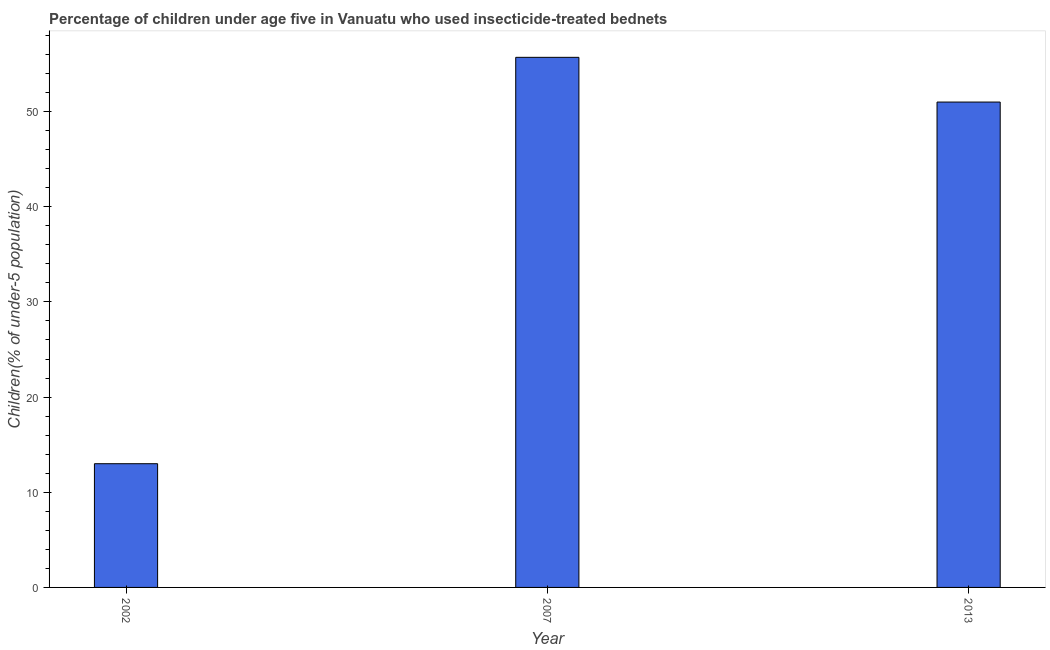Does the graph contain any zero values?
Provide a succinct answer. No. Does the graph contain grids?
Provide a succinct answer. No. What is the title of the graph?
Offer a terse response. Percentage of children under age five in Vanuatu who used insecticide-treated bednets. What is the label or title of the Y-axis?
Ensure brevity in your answer.  Children(% of under-5 population). Across all years, what is the maximum percentage of children who use of insecticide-treated bed nets?
Provide a succinct answer. 55.7. Across all years, what is the minimum percentage of children who use of insecticide-treated bed nets?
Make the answer very short. 13. In which year was the percentage of children who use of insecticide-treated bed nets minimum?
Your answer should be very brief. 2002. What is the sum of the percentage of children who use of insecticide-treated bed nets?
Give a very brief answer. 119.7. What is the average percentage of children who use of insecticide-treated bed nets per year?
Offer a terse response. 39.9. What is the median percentage of children who use of insecticide-treated bed nets?
Provide a succinct answer. 51. In how many years, is the percentage of children who use of insecticide-treated bed nets greater than 10 %?
Give a very brief answer. 3. Do a majority of the years between 2002 and 2007 (inclusive) have percentage of children who use of insecticide-treated bed nets greater than 38 %?
Keep it short and to the point. No. What is the ratio of the percentage of children who use of insecticide-treated bed nets in 2007 to that in 2013?
Give a very brief answer. 1.09. Is the difference between the percentage of children who use of insecticide-treated bed nets in 2007 and 2013 greater than the difference between any two years?
Keep it short and to the point. No. What is the difference between the highest and the second highest percentage of children who use of insecticide-treated bed nets?
Offer a very short reply. 4.7. What is the difference between the highest and the lowest percentage of children who use of insecticide-treated bed nets?
Your response must be concise. 42.7. What is the Children(% of under-5 population) of 2007?
Give a very brief answer. 55.7. What is the Children(% of under-5 population) in 2013?
Offer a terse response. 51. What is the difference between the Children(% of under-5 population) in 2002 and 2007?
Offer a terse response. -42.7. What is the difference between the Children(% of under-5 population) in 2002 and 2013?
Offer a terse response. -38. What is the ratio of the Children(% of under-5 population) in 2002 to that in 2007?
Give a very brief answer. 0.23. What is the ratio of the Children(% of under-5 population) in 2002 to that in 2013?
Your response must be concise. 0.26. What is the ratio of the Children(% of under-5 population) in 2007 to that in 2013?
Make the answer very short. 1.09. 